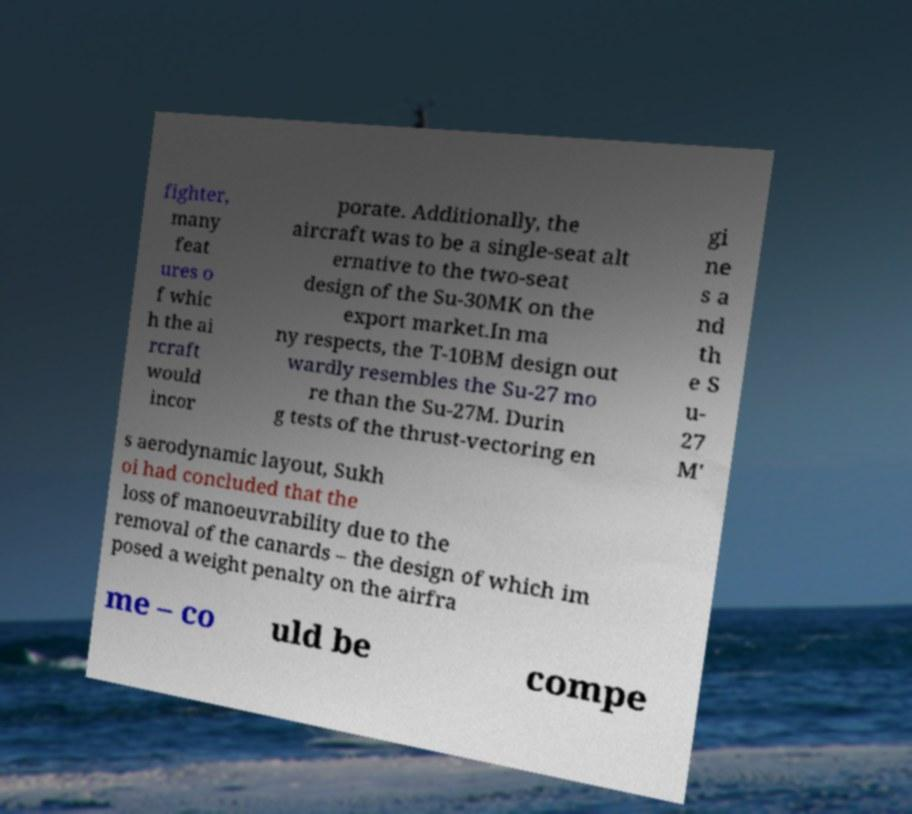Can you read and provide the text displayed in the image?This photo seems to have some interesting text. Can you extract and type it out for me? fighter, many feat ures o f whic h the ai rcraft would incor porate. Additionally, the aircraft was to be a single-seat alt ernative to the two-seat design of the Su-30MK on the export market.In ma ny respects, the T-10BM design out wardly resembles the Su-27 mo re than the Su-27M. Durin g tests of the thrust-vectoring en gi ne s a nd th e S u- 27 M' s aerodynamic layout, Sukh oi had concluded that the loss of manoeuvrability due to the removal of the canards – the design of which im posed a weight penalty on the airfra me – co uld be compe 